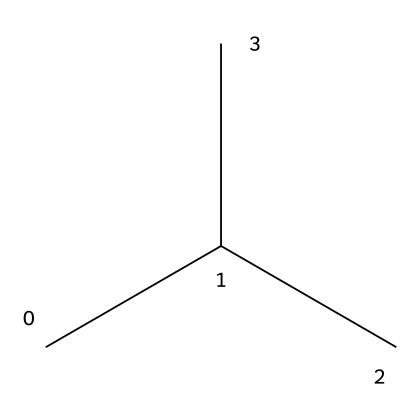What is the molecular formula of R-600a? The SMILES representation shows four carbon atoms (C) and ten hydrogen atoms (H). The molecular formula is derived by counting the number of each type of atom.
Answer: C4H10 How many carbon atoms are present in R-600a? In the structural formula represented by the SMILES, we see that there are four "C" symbols, indicating the presence of four carbon atoms.
Answer: 4 What type of compound is R-600a? R-600a is classified as an alkane because it consists solely of carbon and hydrogen atoms with single bonds connecting them. This classification comes from the presence of only single C-C and C-H bonds.
Answer: alkane How many hydrogen atoms are connected to the central carbon in R-600a? Looking at the structure, the central carbon atom is connected to three other carbon atoms, resulting in a tetrahedral geometry where it must also connect to three hydrogen atoms to satisfy its four bonding requirements.
Answer: 3 Is R-600a a natural refrigerant? R-600a is derived from natural sources and is known for its low environmental impact, qualifying it as a natural refrigerant used in household appliances. This information is based on its sources and applications.
Answer: yes What is the common use for R-600a? R-600a is commonly used in household refrigerators and freezers due to its low environmental impact and efficiency as a refrigerant. This usage is recognized in the industry for its performance in cooling applications.
Answer: refrigeration 